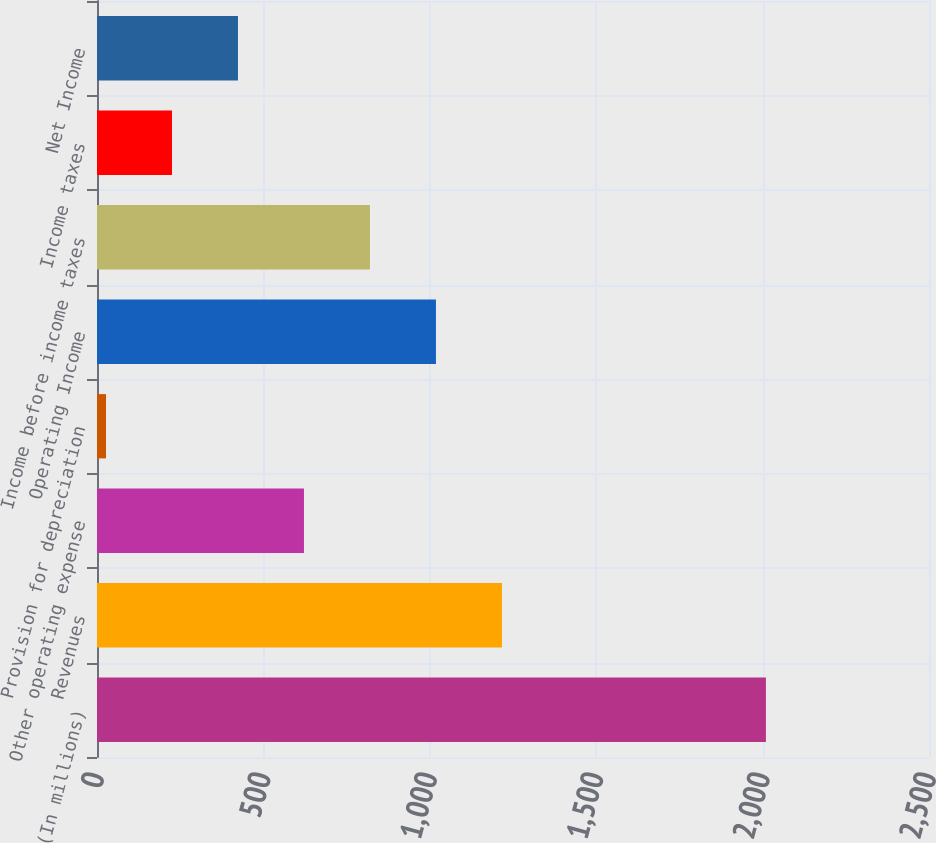Convert chart to OTSL. <chart><loc_0><loc_0><loc_500><loc_500><bar_chart><fcel>(In millions)<fcel>Revenues<fcel>Other operating expense<fcel>Provision for depreciation<fcel>Operating Income<fcel>Income before income taxes<fcel>Income taxes<fcel>Net Income<nl><fcel>2010<fcel>1216.8<fcel>621.9<fcel>27<fcel>1018.5<fcel>820.2<fcel>225.3<fcel>423.6<nl></chart> 